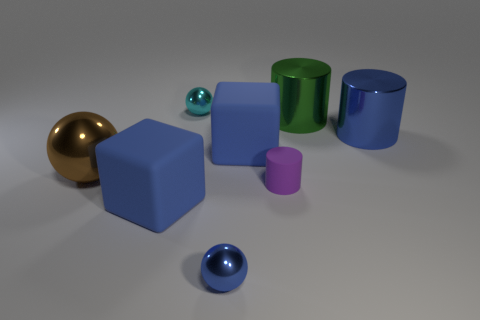Is the number of matte things right of the cyan object greater than the number of brown things?
Offer a very short reply. Yes. The brown object that is the same size as the green object is what shape?
Your response must be concise. Sphere. There is a large blue matte object in front of the big metallic thing that is on the left side of the blue sphere; what number of cyan metallic objects are in front of it?
Make the answer very short. 0. How many rubber objects are large cylinders or tiny objects?
Offer a very short reply. 1. The big thing that is both to the right of the brown ball and to the left of the cyan sphere is what color?
Ensure brevity in your answer.  Blue. There is a cyan object that is behind the blue shiny sphere; does it have the same size as the brown shiny sphere?
Make the answer very short. No. What number of objects are either cylinders that are behind the big blue cylinder or red shiny things?
Your answer should be very brief. 1. Is there a shiny thing that has the same size as the brown shiny sphere?
Keep it short and to the point. Yes. What is the material of the cylinder that is the same size as the cyan object?
Offer a terse response. Rubber. The metallic thing that is left of the small blue object and behind the big brown shiny thing has what shape?
Make the answer very short. Sphere. 